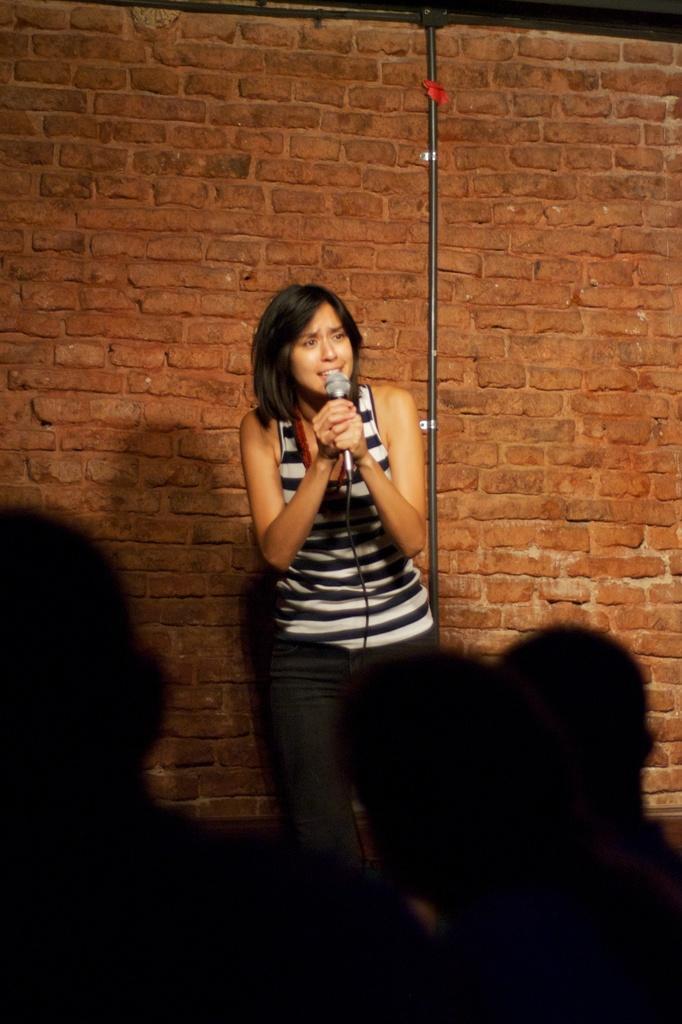Describe this image in one or two sentences. This image consists of a woman holding a mic and singing. In the background, we can see a wall made up of bricks. And there is a pipe fixed to the wall. At the bottom, we can see the shadow of the people. 